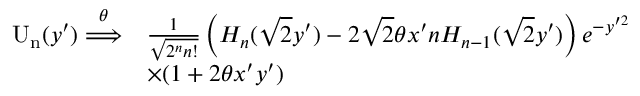<formula> <loc_0><loc_0><loc_500><loc_500>\begin{array} { r l } { U _ { n } ( y ^ { \prime } ) \overset { \theta } { \Longrightarrow } } & { \frac { 1 } { \sqrt { 2 ^ { n } n ! } } \left ( H _ { n } ( \sqrt { 2 } y ^ { \prime } ) - 2 \sqrt { 2 } \theta x ^ { \prime } n H _ { n - 1 } ( \sqrt { 2 } y ^ { \prime } ) \right ) e ^ { - y ^ { \prime 2 } } } \\ & { \times ( 1 + 2 \theta x ^ { \prime } y ^ { \prime } ) } \end{array}</formula> 